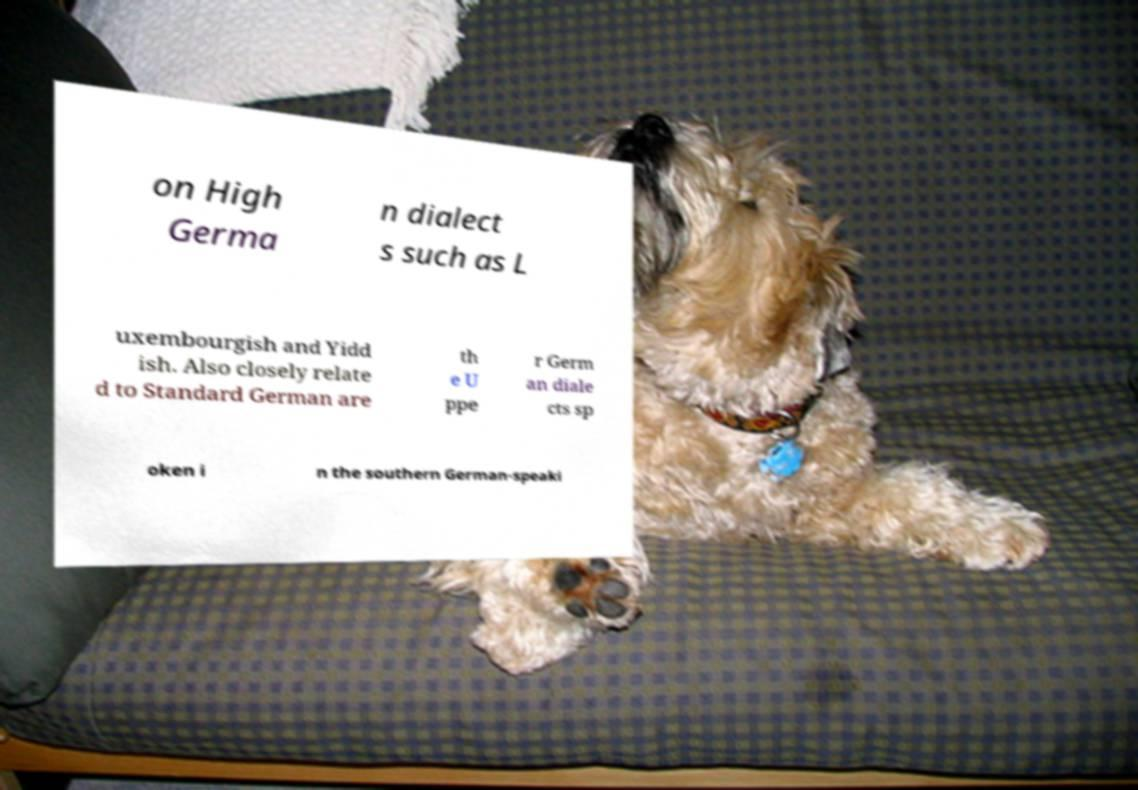Please identify and transcribe the text found in this image. on High Germa n dialect s such as L uxembourgish and Yidd ish. Also closely relate d to Standard German are th e U ppe r Germ an diale cts sp oken i n the southern German-speaki 